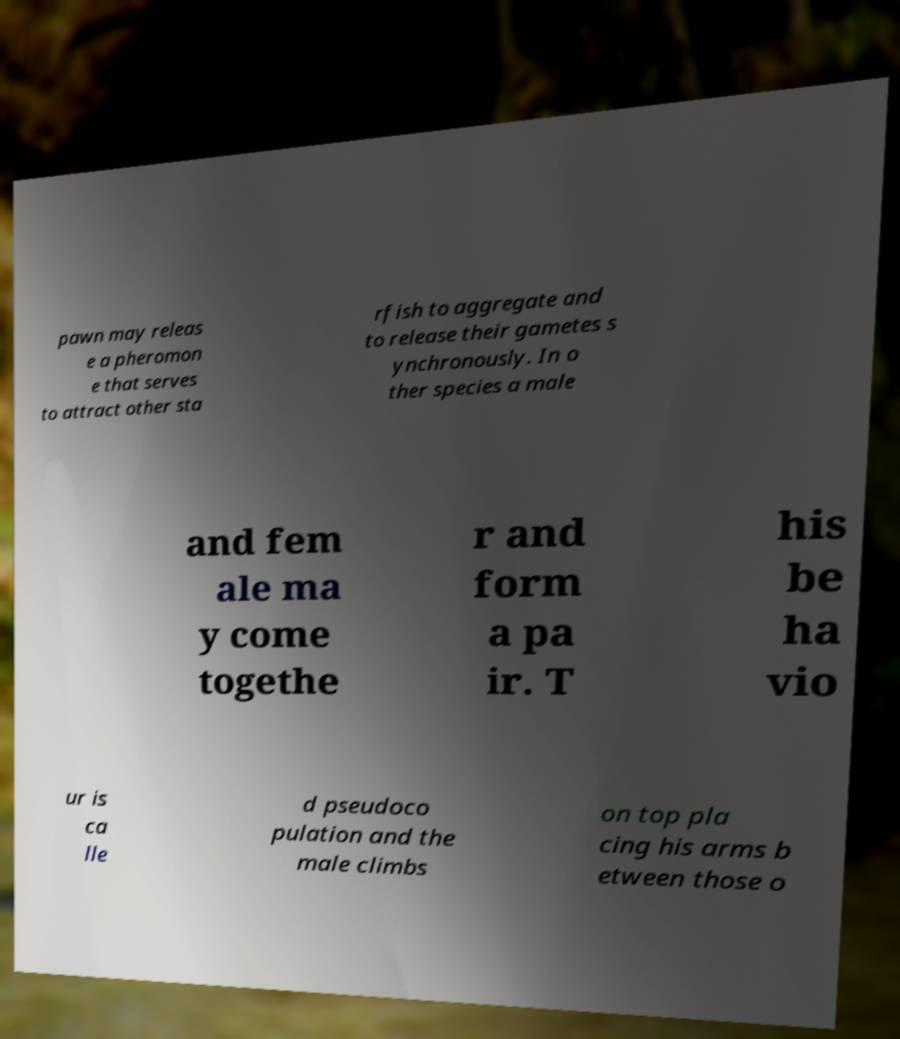Could you extract and type out the text from this image? pawn may releas e a pheromon e that serves to attract other sta rfish to aggregate and to release their gametes s ynchronously. In o ther species a male and fem ale ma y come togethe r and form a pa ir. T his be ha vio ur is ca lle d pseudoco pulation and the male climbs on top pla cing his arms b etween those o 